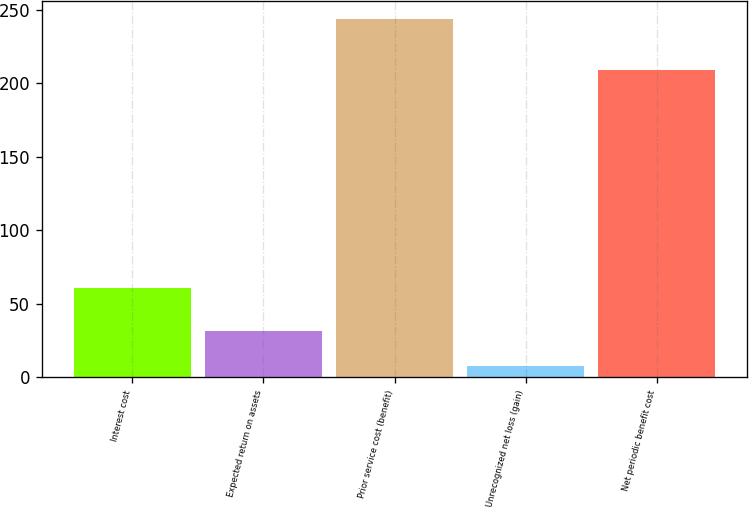Convert chart. <chart><loc_0><loc_0><loc_500><loc_500><bar_chart><fcel>Interest cost<fcel>Expected return on assets<fcel>Prior service cost (benefit)<fcel>Unrecognized net loss (gain)<fcel>Net periodic benefit cost<nl><fcel>61<fcel>31.6<fcel>244<fcel>8<fcel>209<nl></chart> 